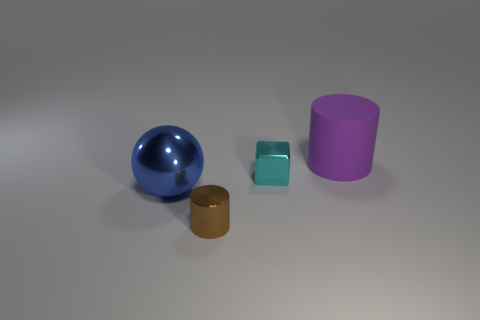Are there any other things of the same color as the cube?
Offer a terse response. No. Are there any other things that have the same material as the blue ball?
Give a very brief answer. Yes. There is a tiny thing that is in front of the big blue sphere; is it the same shape as the large blue metallic thing?
Provide a succinct answer. No. What material is the big sphere?
Your response must be concise. Metal. There is a object that is in front of the large thing that is on the left side of the cylinder on the left side of the cyan object; what is its shape?
Give a very brief answer. Cylinder. What number of other objects are there of the same shape as the big metal object?
Your answer should be compact. 0. What number of purple rubber objects are there?
Provide a succinct answer. 1. How many things are either shiny cylinders or blue metal cubes?
Offer a very short reply. 1. There is a tiny cyan shiny object; are there any cylinders left of it?
Make the answer very short. Yes. Are there more cyan metallic objects on the right side of the brown shiny thing than tiny metallic cylinders that are right of the cyan thing?
Offer a terse response. Yes. 